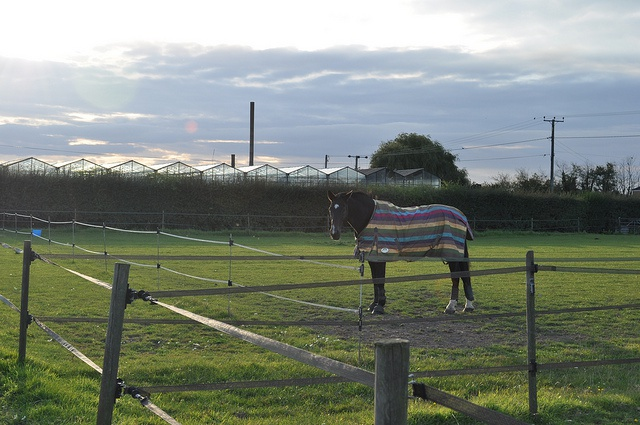Describe the objects in this image and their specific colors. I can see a horse in white, black, gray, and purple tones in this image. 